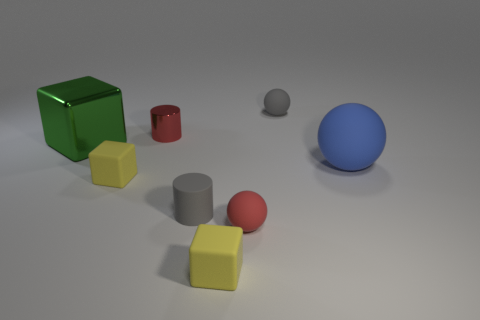Add 1 cyan metallic things. How many objects exist? 9 Subtract all cylinders. How many objects are left? 6 Subtract all big green metallic blocks. Subtract all big green cubes. How many objects are left? 6 Add 1 small rubber spheres. How many small rubber spheres are left? 3 Add 1 tiny gray cylinders. How many tiny gray cylinders exist? 2 Subtract 0 purple balls. How many objects are left? 8 